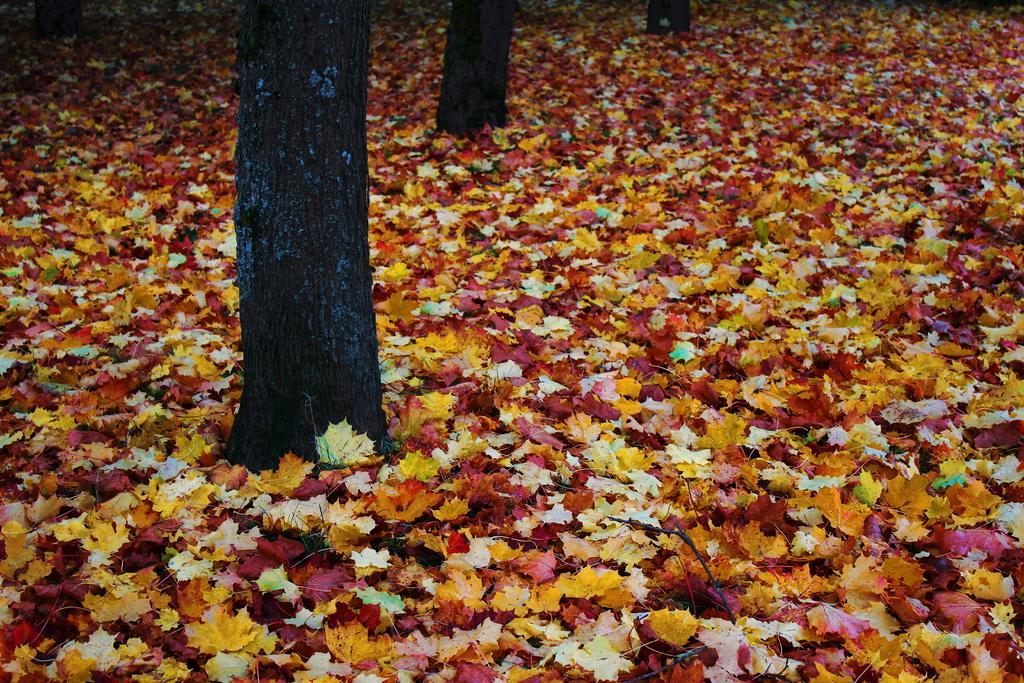Could you give a brief overview of what you see in this image? In this image we can see some trees and on the ground we can see some leaves which are in different colors. 